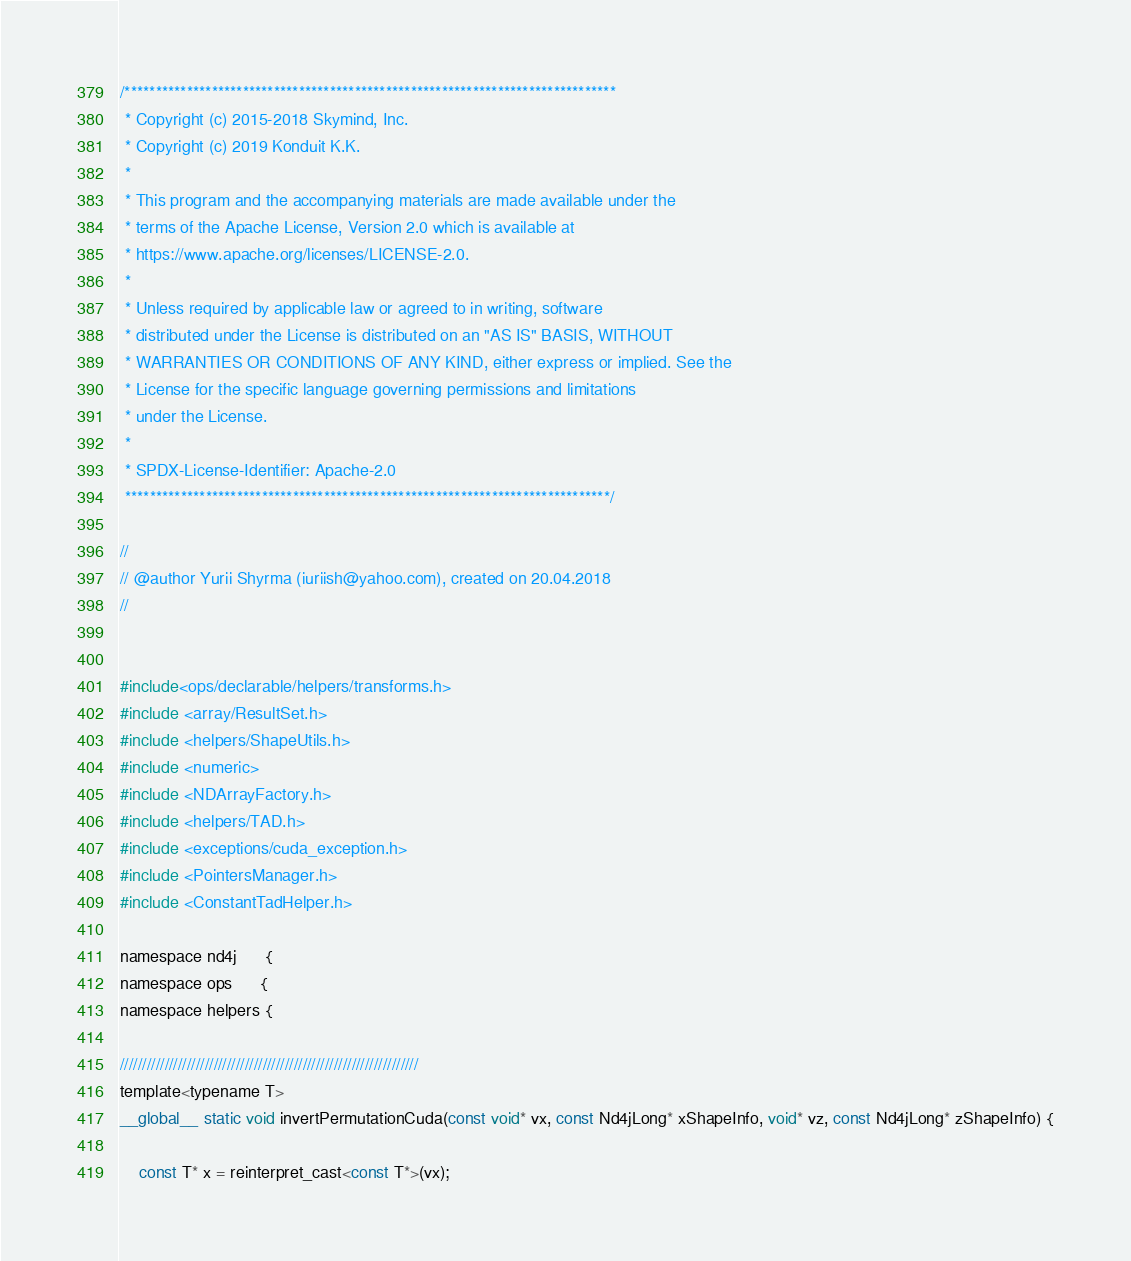<code> <loc_0><loc_0><loc_500><loc_500><_Cuda_>/*******************************************************************************
 * Copyright (c) 2015-2018 Skymind, Inc.
 * Copyright (c) 2019 Konduit K.K.
 *
 * This program and the accompanying materials are made available under the
 * terms of the Apache License, Version 2.0 which is available at
 * https://www.apache.org/licenses/LICENSE-2.0.
 *
 * Unless required by applicable law or agreed to in writing, software
 * distributed under the License is distributed on an "AS IS" BASIS, WITHOUT
 * WARRANTIES OR CONDITIONS OF ANY KIND, either express or implied. See the
 * License for the specific language governing permissions and limitations
 * under the License.
 *
 * SPDX-License-Identifier: Apache-2.0
 ******************************************************************************/

//
// @author Yurii Shyrma (iuriish@yahoo.com), created on 20.04.2018
//


#include<ops/declarable/helpers/transforms.h>
#include <array/ResultSet.h>
#include <helpers/ShapeUtils.h>
#include <numeric>
#include <NDArrayFactory.h>
#include <helpers/TAD.h>
#include <exceptions/cuda_exception.h>
#include <PointersManager.h>
#include <ConstantTadHelper.h>

namespace nd4j 	  {
namespace ops 	  {
namespace helpers {

///////////////////////////////////////////////////////////////////
template<typename T>
__global__ static void invertPermutationCuda(const void* vx, const Nd4jLong* xShapeInfo, void* vz, const Nd4jLong* zShapeInfo) {

    const T* x = reinterpret_cast<const T*>(vx);</code> 